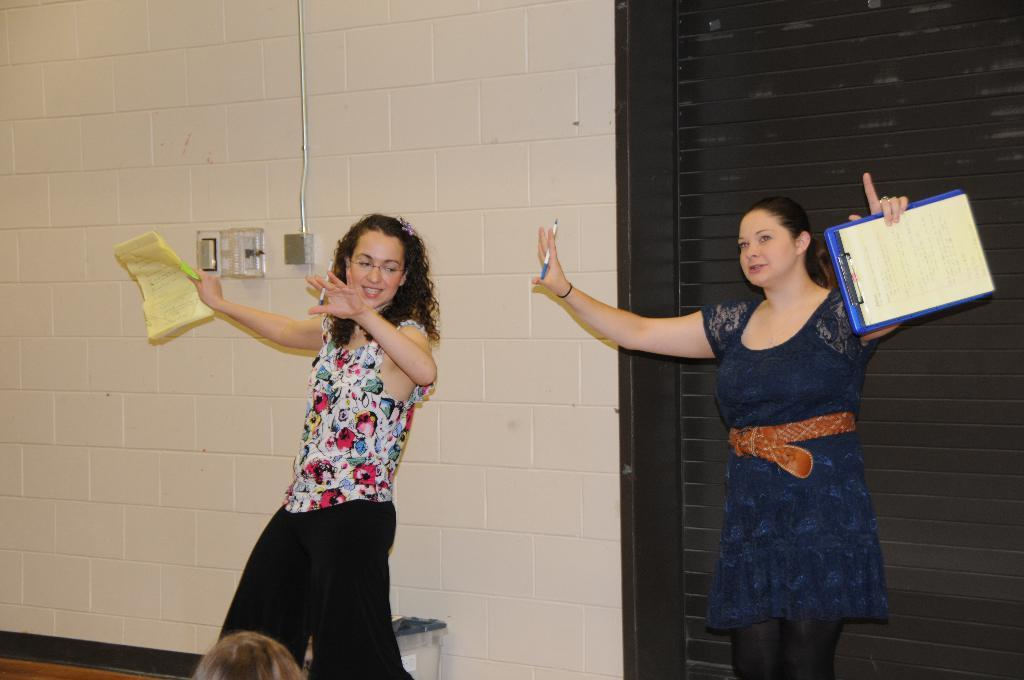What are the women in the image holding? The women are holding pens, papers, and a plank in the image. What can be seen in the background of the image? There is a wall, a pipeline, an electric shaft, and a grill in the background of the image. How many chickens are sitting on the plank held by the women in the image? There are no chickens present in the image; the women are holding pens, papers, and a plank. What type of conversation are the women having in the image? The image does not depict any conversation or talking, so it cannot be determined what type of conversation the women might be having. 